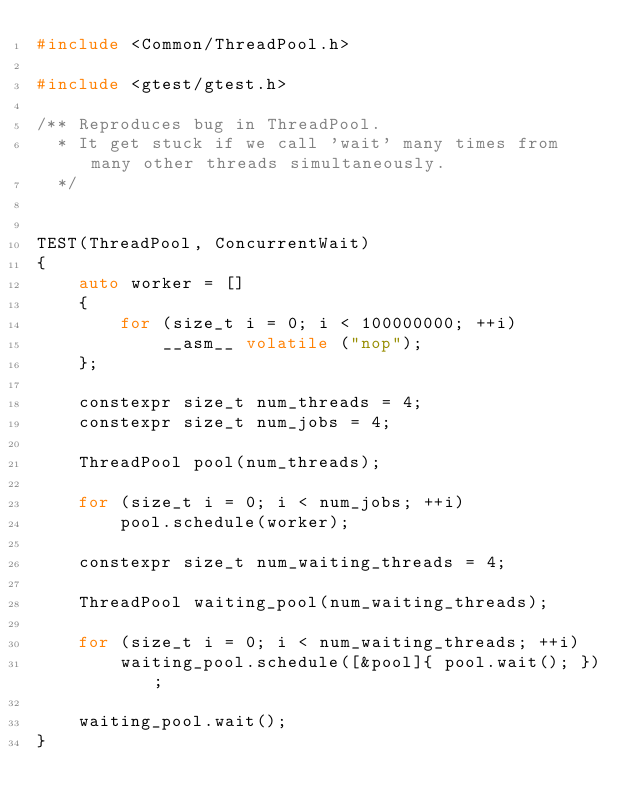Convert code to text. <code><loc_0><loc_0><loc_500><loc_500><_C++_>#include <Common/ThreadPool.h>

#include <gtest/gtest.h>

/** Reproduces bug in ThreadPool.
  * It get stuck if we call 'wait' many times from many other threads simultaneously.
  */


TEST(ThreadPool, ConcurrentWait)
{
    auto worker = []
    {
        for (size_t i = 0; i < 100000000; ++i)
            __asm__ volatile ("nop");
    };

    constexpr size_t num_threads = 4;
    constexpr size_t num_jobs = 4;

    ThreadPool pool(num_threads);

    for (size_t i = 0; i < num_jobs; ++i)
        pool.schedule(worker);

    constexpr size_t num_waiting_threads = 4;

    ThreadPool waiting_pool(num_waiting_threads);

    for (size_t i = 0; i < num_waiting_threads; ++i)
        waiting_pool.schedule([&pool]{ pool.wait(); });

    waiting_pool.wait();
}
</code> 